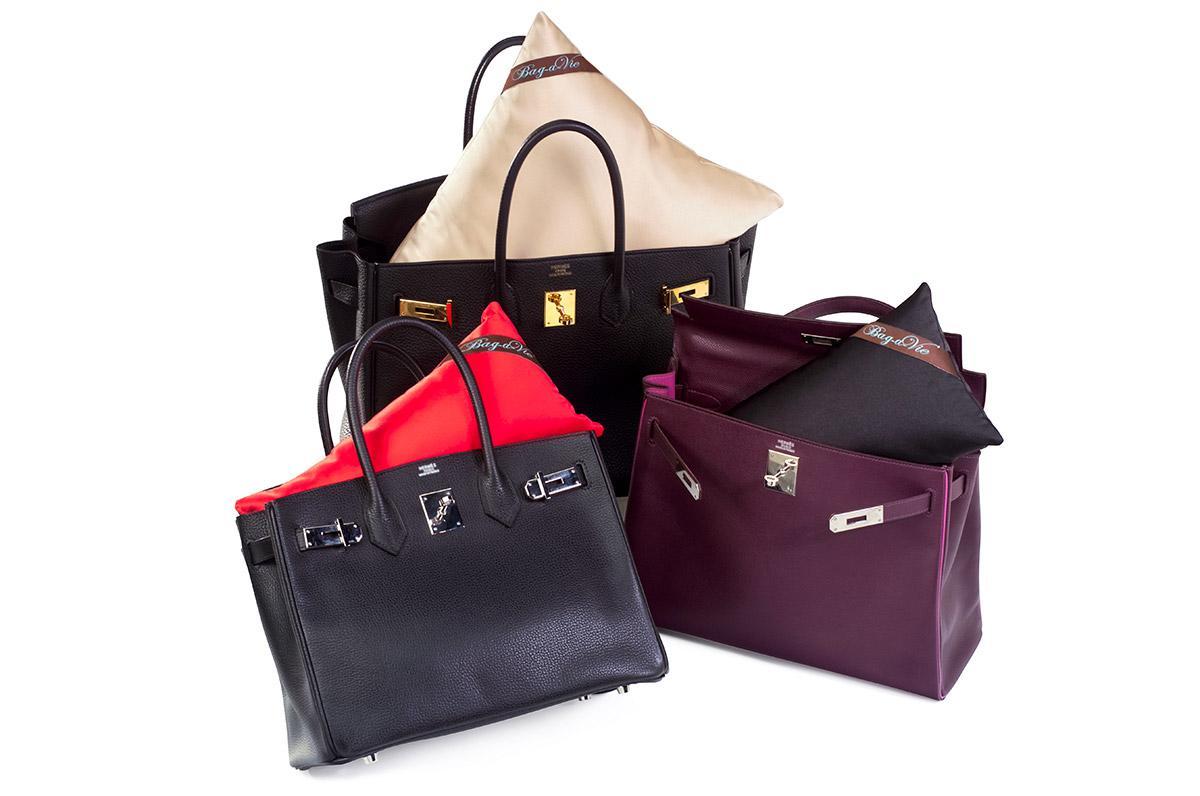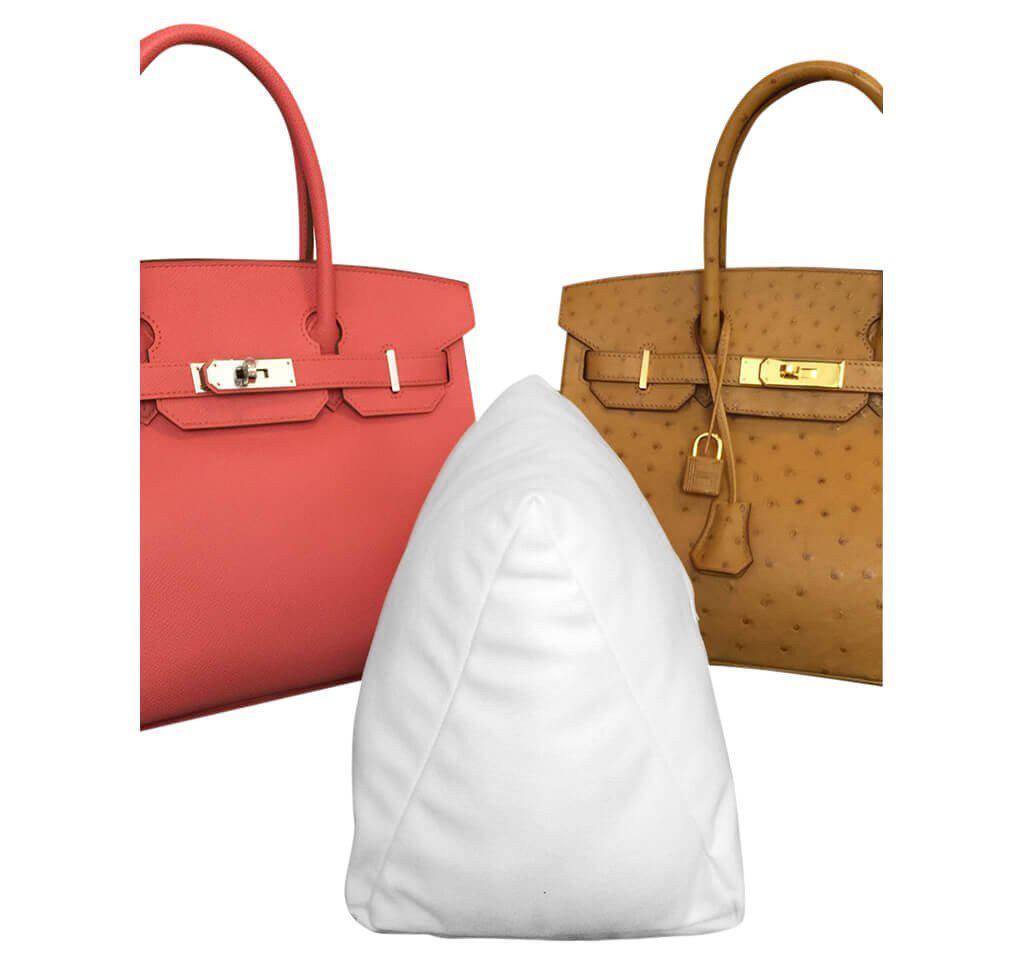The first image is the image on the left, the second image is the image on the right. Examine the images to the left and right. Is the description "The right image shows an upright coral-colored handbag to the left of an upright tan handbag, and a white wedge pillow is in front of them." accurate? Answer yes or no. Yes. The first image is the image on the left, the second image is the image on the right. Given the left and right images, does the statement "The image on the right shows two purses and a purse pillow." hold true? Answer yes or no. Yes. 